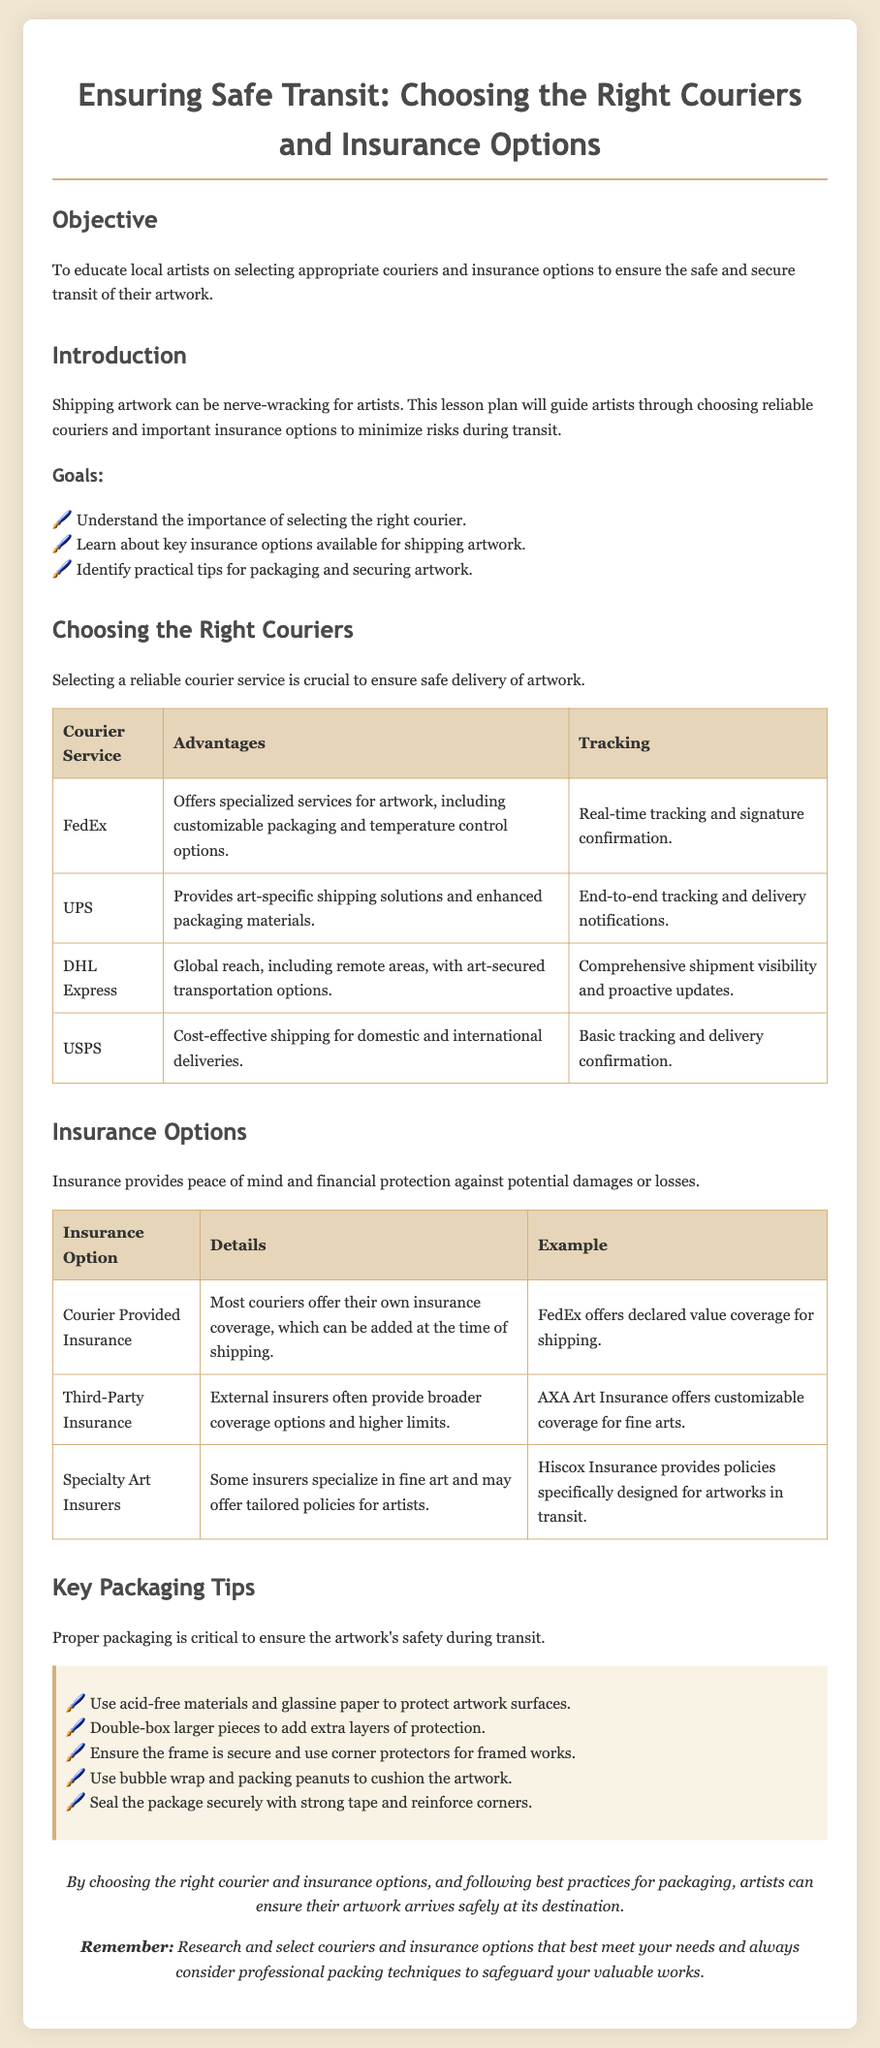What is the objective of the lesson? The objective is stated clearly as "To educate local artists on selecting appropriate couriers and insurance options to ensure the safe and secure transit of their artwork."
Answer: To educate local artists on selecting appropriate couriers and insurance options Which courier service offers specialized services for artwork? The table lists FedEx as offering specialized services for artwork, including customizable packaging and temperature control options.
Answer: FedEx What type of tracking does UPS provide? The document mentions that UPS offers end-to-end tracking and delivery notifications.
Answer: End-to-end tracking What is one example of specialty art insurance mentioned? The document lists Hiscox Insurance as an example of a specialty art insurer that provides tailored policies for artworks in transit.
Answer: Hiscox Insurance How many insurance options are discussed in the document? The document outlines three insurance options: Courier Provided Insurance, Third-Party Insurance, and Specialty Art Insurers.
Answer: Three What should you use to protect artwork surfaces? One of the key packaging tips advises using acid-free materials and glassine paper to protect artwork surfaces.
Answer: Acid-free materials and glassine paper Which courier has global reach including remote areas? DHL Express is identified in the document as having a global reach, including remote areas.
Answer: DHL Express What is an example of third-party insurance? The document provides AXA Art Insurance as an example of third-party insurance that offers customizable coverage for fine arts.
Answer: AXA Art Insurance What is recommended for larger pieces of artwork? The document recommends double-boxing larger pieces to add extra layers of protection.
Answer: Double-boxing 